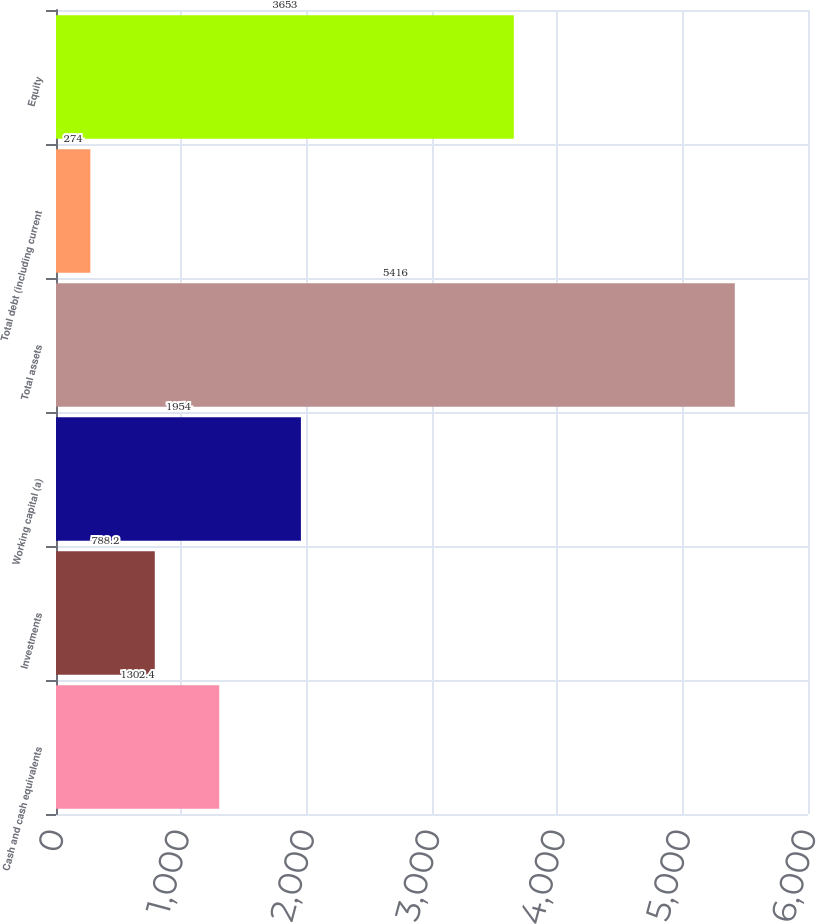<chart> <loc_0><loc_0><loc_500><loc_500><bar_chart><fcel>Cash and cash equivalents<fcel>Investments<fcel>Working capital (a)<fcel>Total assets<fcel>Total debt (including current<fcel>Equity<nl><fcel>1302.4<fcel>788.2<fcel>1954<fcel>5416<fcel>274<fcel>3653<nl></chart> 